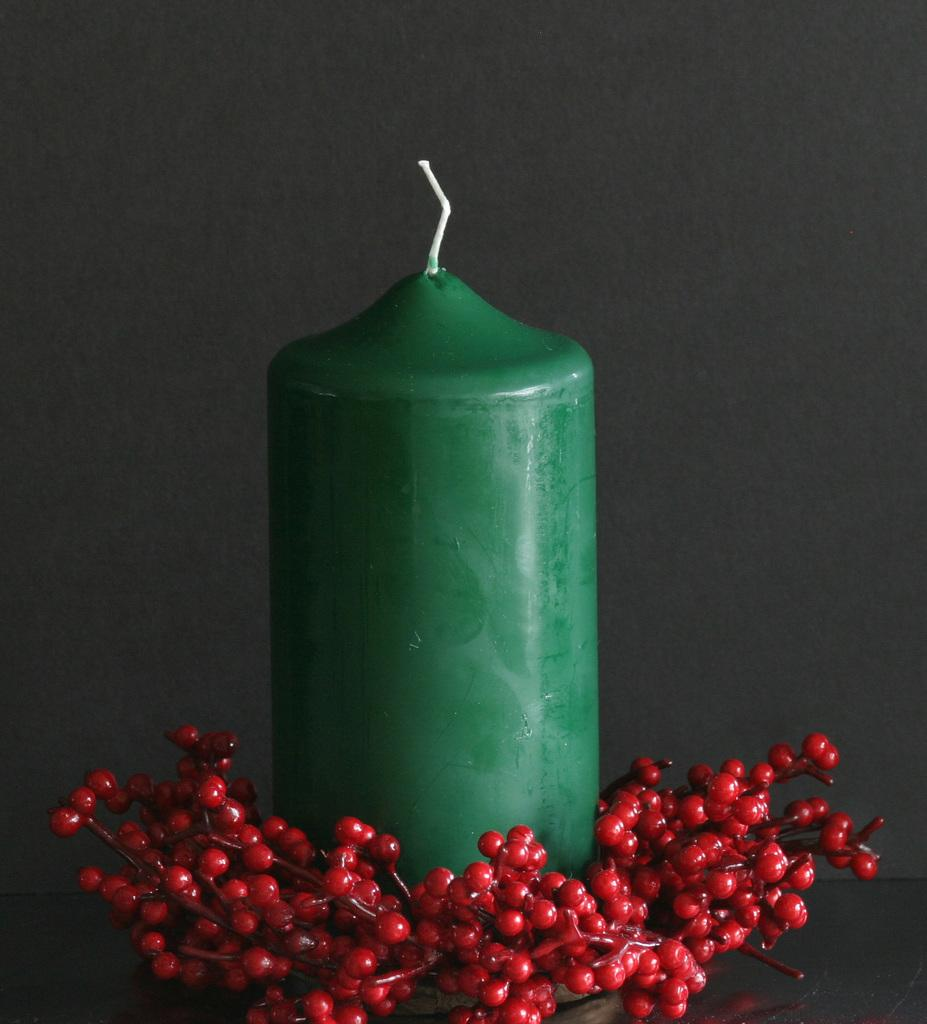What type of candle is in the image? There is a green candle in the image. What other objects can be seen on the table in the image? There are artificial fruits on the table in the image. What is behind the candle in the image? There is a wall behind the candle in the image. What type of plant is growing on the wall in the image? There is no plant growing on the wall in the image; it only shows a wall behind the candle. 